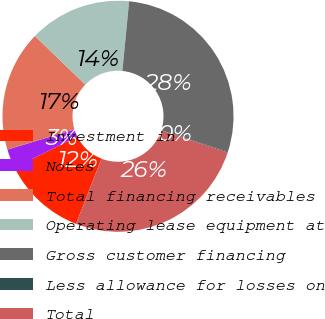Convert chart to OTSL. <chart><loc_0><loc_0><loc_500><loc_500><pie_chart><fcel>Investment in<fcel>Notes<fcel>Total financing receivables<fcel>Operating lease equipment at<fcel>Gross customer financing<fcel>Less allowance for losses on<fcel>Total<nl><fcel>11.72%<fcel>2.7%<fcel>16.89%<fcel>14.31%<fcel>28.42%<fcel>0.12%<fcel>25.84%<nl></chart> 